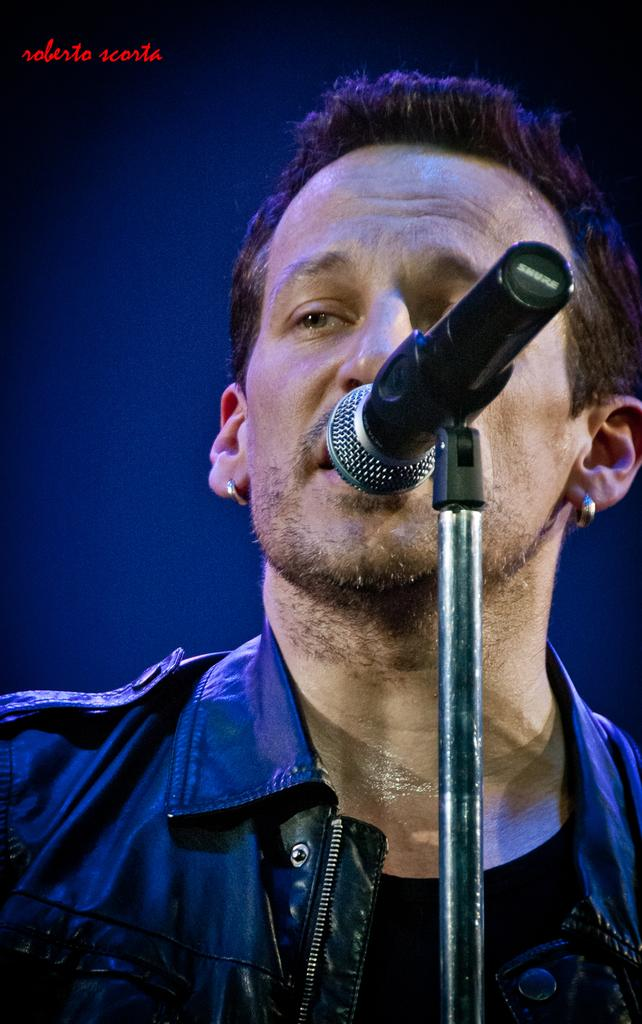Who is the main subject in the image? There is a man in the image. What is the man wearing? The man is wearing a black jacket. What object is in front of the man? There is a microphone (mic) in front of the man. Can you see the seashore in the background of the image? There is no seashore visible in the image. What type of play is the man participating in with the microphone? The image does not indicate that the man is participating in any play; he is simply standing in front of a microphone. 